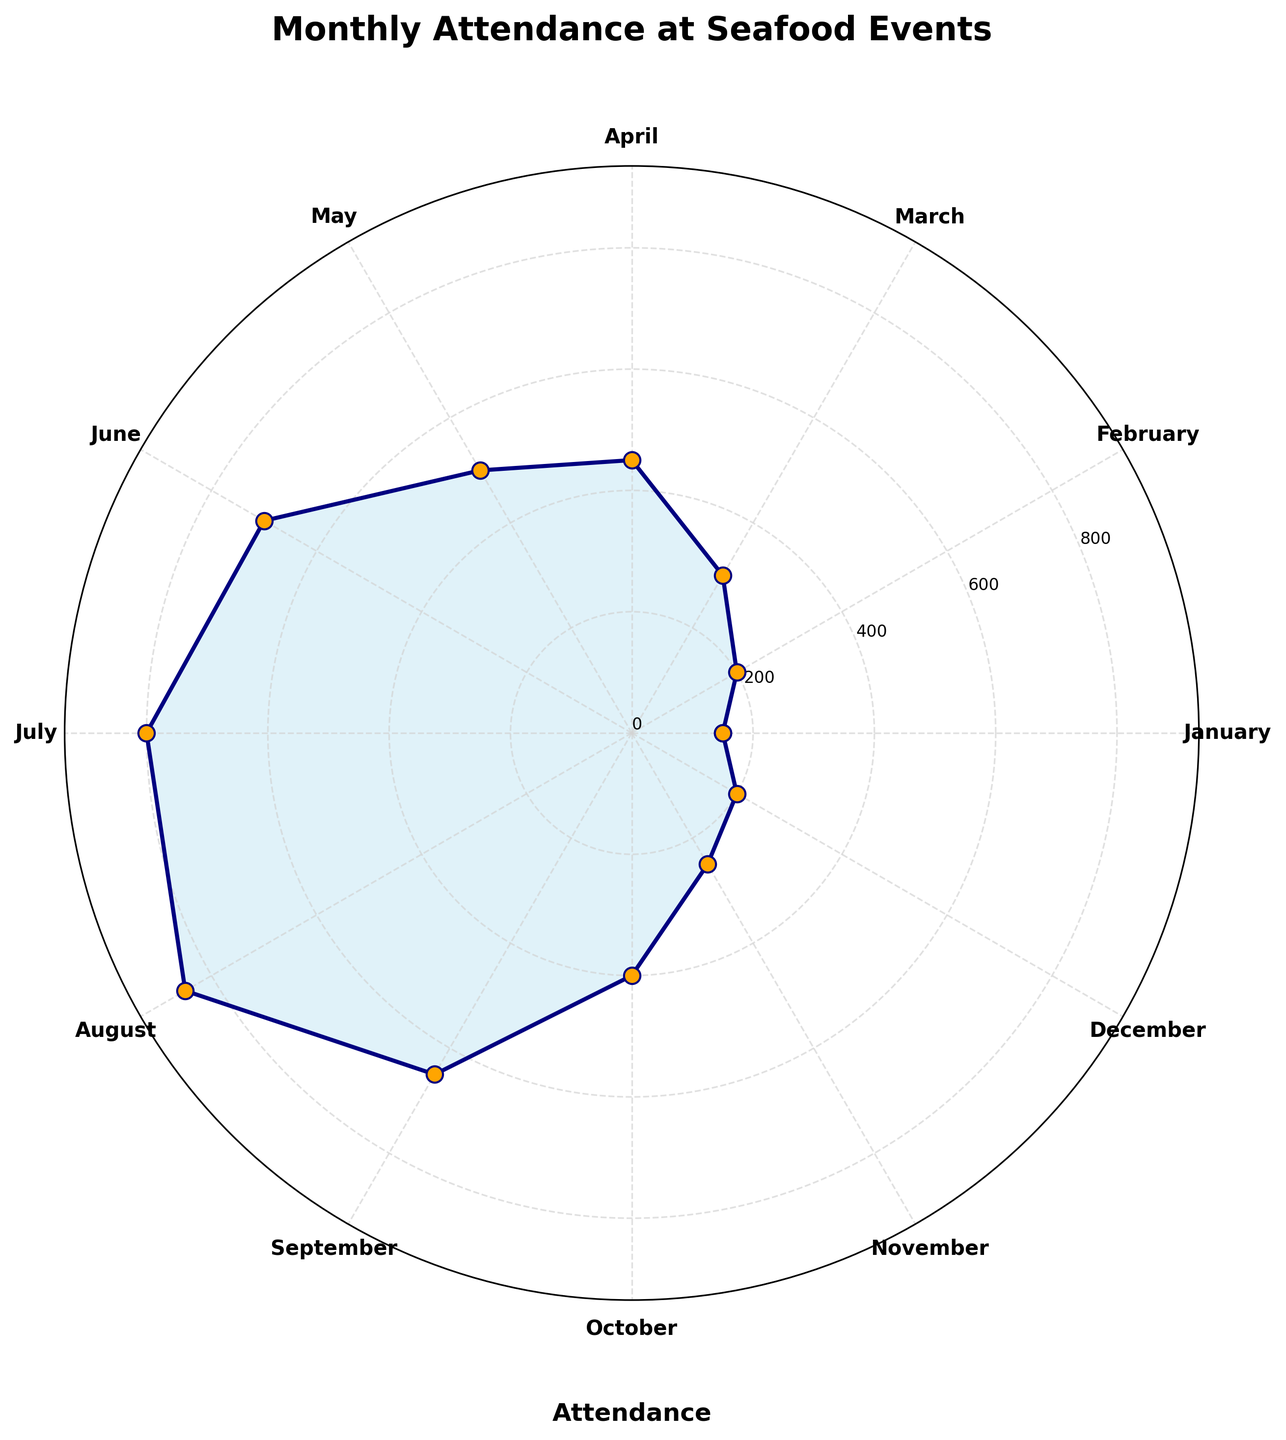What is the title of the chart? The title of the chart is typically found at the top or center of the figure, often highlighted in bold. In this case, it is placed at the top center of the chart.
Answer: Monthly Attendance at Seafood Events Which month has the highest attendance? From the polar plot, the highest peak or the largest area segment represents the month with the highest attendance. Here, August has the highest peak.
Answer: August What is the attendance value for May? Find the segment labeled 'May' and trace the radial line to see where it intersects with the attendance values around the circular plot. The attendance for May is 500.
Answer: 500 What's the total attendance for the first quarter of the year (January, February, March)? Sum the attendance values for January, February, and March. January: 150, February: 200, March: 300. Therefore, 150 + 200 + 300 = 650.
Answer: 650 Compare the attendance between June and December. Which month had higher attendance? Locate the segments for June and December and compare their lengths/values. June has 700, and December has 200; June is higher.
Answer: June How much more attendance was there in July compared to November? Subtract November's attendance from July's attendance. July: 800, November: 250. So, 800 - 250 = 550.
Answer: 550 What is the average monthly attendance? Sum the attendance for all months and divide by 12 (the number of months). Total attendance: 5100. Average: 5100 / 12 = 425.
Answer: 425 What months had attendance values above 600? Locate all segments with attendance extending beyond the 600 mark. These months are June, July, August, and September.
Answer: June, July, August, September What is the second-highest attendance value and which month does it correspond to? Identify the second-highest peak in the polar plot. The highest is August (850), so the second-highest is July (800).
Answer: 800 in July Which month had the lowest attendance and what's the value? Find the smallest segment in the plot. January and December are tied for the lowest attendance at 150.
Answer: January and December, 150 